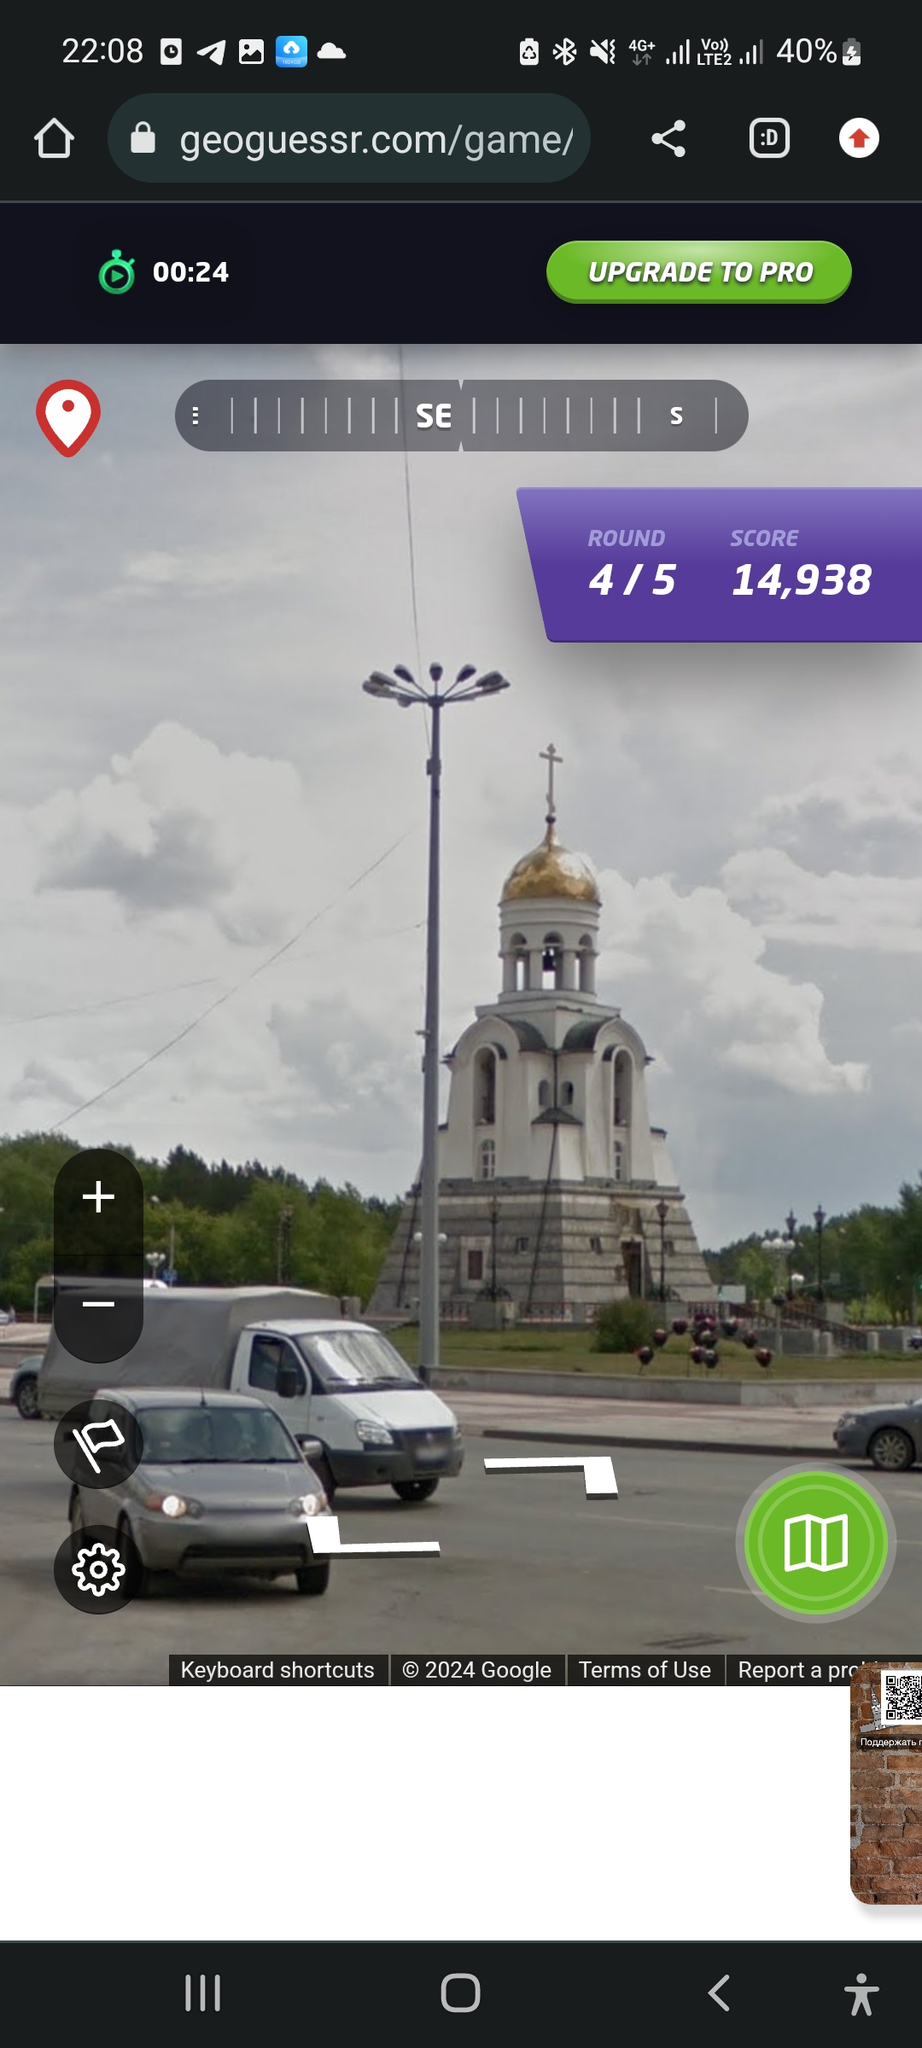Where is this building situated (guess the address as close as you can) The building is located at 1 Sobornaya Square, Yekaterinburg, Russia, 620075. 